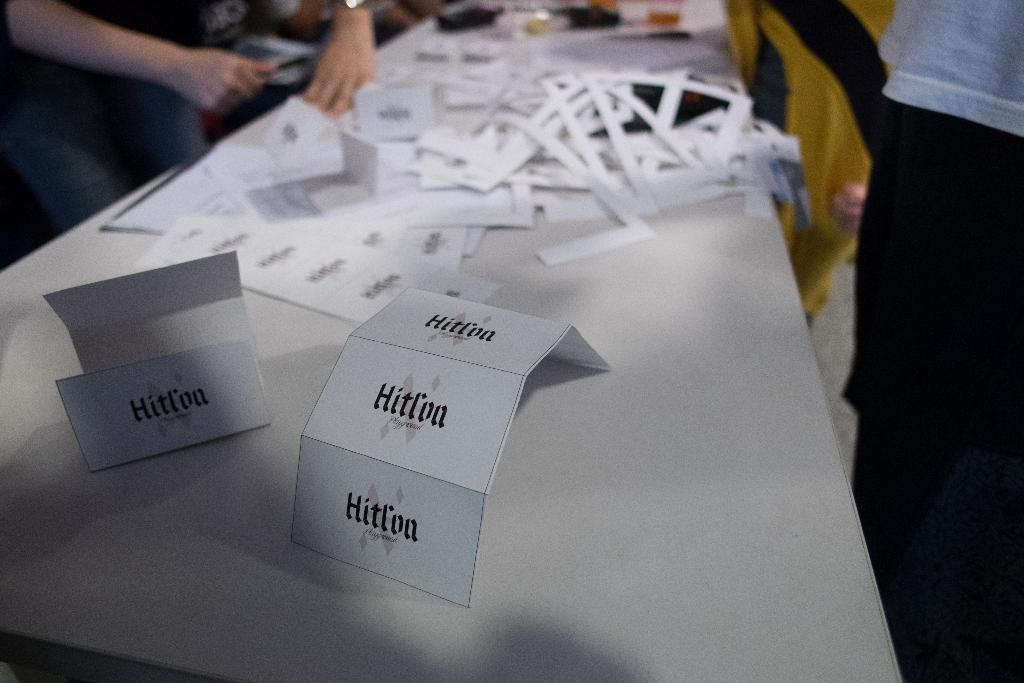What is on the table in the image? There are cards, papers, and other objects on the table. How many persons are standing in the image? There are persons standing on both the left and right sides of the image. What type of station can be seen in the image? There is no station present in the image. Can you see an airplane in the image? There is no airplane present in the image. 